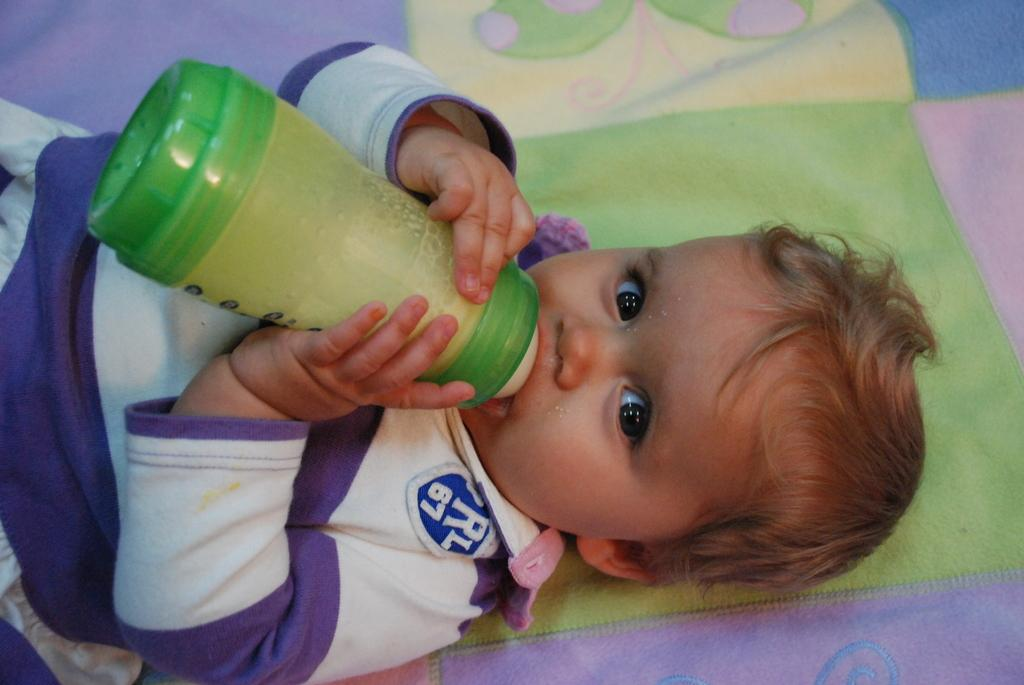Who is the main subject in the image? There is a boy in the image. What is the boy doing in the image? The boy is lying on a bed. What is the boy holding in the image? The boy is holding a bottle. What type of noise can be heard coming from the sink in the image? There is no sink present in the image, so it's not possible to determine what, if any, noise might be heard. 